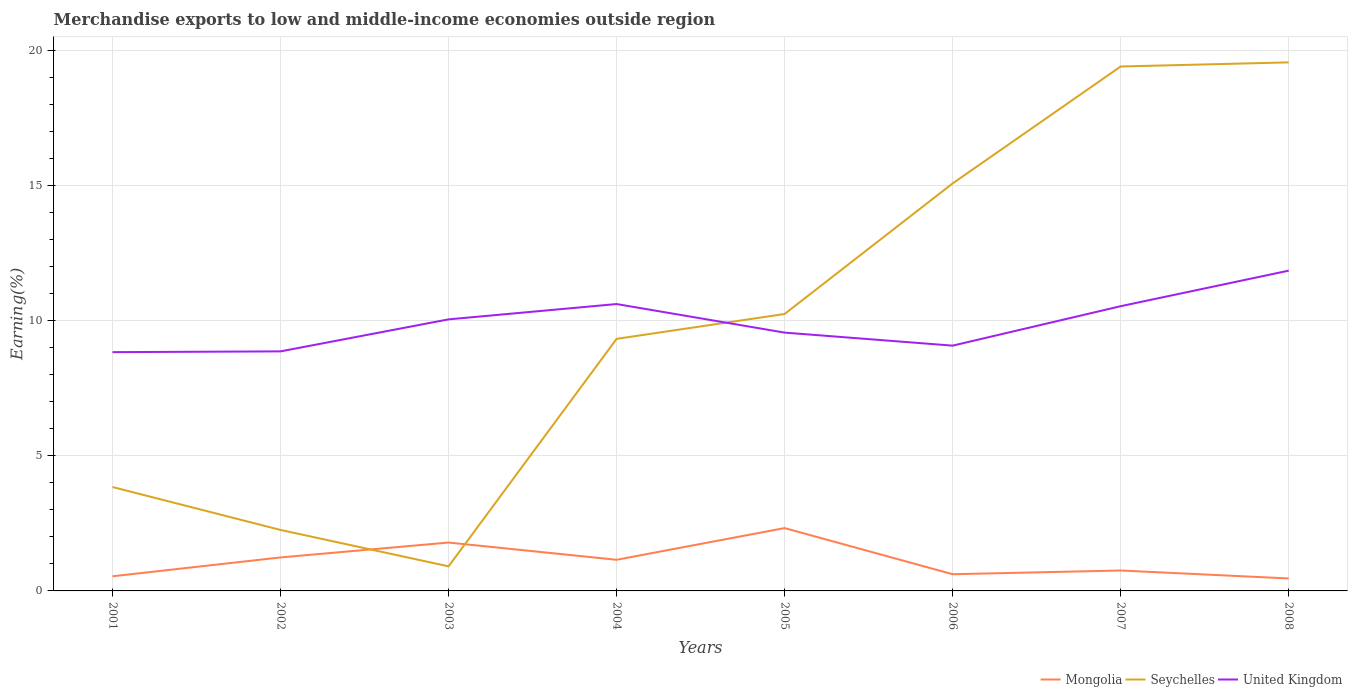Is the number of lines equal to the number of legend labels?
Your answer should be compact. Yes. Across all years, what is the maximum percentage of amount earned from merchandise exports in United Kingdom?
Provide a short and direct response. 8.83. In which year was the percentage of amount earned from merchandise exports in Seychelles maximum?
Provide a succinct answer. 2003. What is the total percentage of amount earned from merchandise exports in Mongolia in the graph?
Keep it short and to the point. 1.03. What is the difference between the highest and the second highest percentage of amount earned from merchandise exports in United Kingdom?
Your answer should be compact. 3.01. How many lines are there?
Offer a terse response. 3. How many years are there in the graph?
Provide a succinct answer. 8. Where does the legend appear in the graph?
Make the answer very short. Bottom right. How many legend labels are there?
Your answer should be compact. 3. How are the legend labels stacked?
Give a very brief answer. Horizontal. What is the title of the graph?
Make the answer very short. Merchandise exports to low and middle-income economies outside region. Does "Uzbekistan" appear as one of the legend labels in the graph?
Your response must be concise. No. What is the label or title of the X-axis?
Offer a very short reply. Years. What is the label or title of the Y-axis?
Ensure brevity in your answer.  Earning(%). What is the Earning(%) of Mongolia in 2001?
Give a very brief answer. 0.54. What is the Earning(%) in Seychelles in 2001?
Make the answer very short. 3.84. What is the Earning(%) of United Kingdom in 2001?
Your answer should be very brief. 8.83. What is the Earning(%) of Mongolia in 2002?
Your answer should be very brief. 1.24. What is the Earning(%) of Seychelles in 2002?
Ensure brevity in your answer.  2.25. What is the Earning(%) in United Kingdom in 2002?
Your answer should be very brief. 8.86. What is the Earning(%) in Mongolia in 2003?
Make the answer very short. 1.79. What is the Earning(%) of Seychelles in 2003?
Your answer should be very brief. 0.91. What is the Earning(%) in United Kingdom in 2003?
Offer a terse response. 10.04. What is the Earning(%) of Mongolia in 2004?
Ensure brevity in your answer.  1.15. What is the Earning(%) of Seychelles in 2004?
Offer a very short reply. 9.32. What is the Earning(%) of United Kingdom in 2004?
Make the answer very short. 10.61. What is the Earning(%) in Mongolia in 2005?
Offer a terse response. 2.32. What is the Earning(%) in Seychelles in 2005?
Keep it short and to the point. 10.24. What is the Earning(%) in United Kingdom in 2005?
Your response must be concise. 9.55. What is the Earning(%) of Mongolia in 2006?
Keep it short and to the point. 0.62. What is the Earning(%) in Seychelles in 2006?
Provide a short and direct response. 15.07. What is the Earning(%) of United Kingdom in 2006?
Offer a very short reply. 9.07. What is the Earning(%) of Mongolia in 2007?
Ensure brevity in your answer.  0.76. What is the Earning(%) in Seychelles in 2007?
Your answer should be compact. 19.39. What is the Earning(%) of United Kingdom in 2007?
Your answer should be compact. 10.53. What is the Earning(%) of Mongolia in 2008?
Keep it short and to the point. 0.46. What is the Earning(%) of Seychelles in 2008?
Provide a succinct answer. 19.54. What is the Earning(%) in United Kingdom in 2008?
Ensure brevity in your answer.  11.84. Across all years, what is the maximum Earning(%) in Mongolia?
Provide a succinct answer. 2.32. Across all years, what is the maximum Earning(%) in Seychelles?
Ensure brevity in your answer.  19.54. Across all years, what is the maximum Earning(%) of United Kingdom?
Ensure brevity in your answer.  11.84. Across all years, what is the minimum Earning(%) of Mongolia?
Offer a terse response. 0.46. Across all years, what is the minimum Earning(%) in Seychelles?
Your response must be concise. 0.91. Across all years, what is the minimum Earning(%) in United Kingdom?
Give a very brief answer. 8.83. What is the total Earning(%) in Mongolia in the graph?
Give a very brief answer. 8.88. What is the total Earning(%) in Seychelles in the graph?
Give a very brief answer. 80.57. What is the total Earning(%) of United Kingdom in the graph?
Offer a terse response. 79.33. What is the difference between the Earning(%) of Mongolia in 2001 and that in 2002?
Your response must be concise. -0.7. What is the difference between the Earning(%) of Seychelles in 2001 and that in 2002?
Your answer should be compact. 1.59. What is the difference between the Earning(%) of United Kingdom in 2001 and that in 2002?
Make the answer very short. -0.03. What is the difference between the Earning(%) of Mongolia in 2001 and that in 2003?
Provide a short and direct response. -1.25. What is the difference between the Earning(%) in Seychelles in 2001 and that in 2003?
Your response must be concise. 2.93. What is the difference between the Earning(%) in United Kingdom in 2001 and that in 2003?
Provide a short and direct response. -1.21. What is the difference between the Earning(%) in Mongolia in 2001 and that in 2004?
Offer a very short reply. -0.61. What is the difference between the Earning(%) in Seychelles in 2001 and that in 2004?
Your answer should be compact. -5.48. What is the difference between the Earning(%) in United Kingdom in 2001 and that in 2004?
Your answer should be very brief. -1.78. What is the difference between the Earning(%) of Mongolia in 2001 and that in 2005?
Ensure brevity in your answer.  -1.78. What is the difference between the Earning(%) of Seychelles in 2001 and that in 2005?
Provide a short and direct response. -6.4. What is the difference between the Earning(%) in United Kingdom in 2001 and that in 2005?
Ensure brevity in your answer.  -0.72. What is the difference between the Earning(%) of Mongolia in 2001 and that in 2006?
Provide a short and direct response. -0.08. What is the difference between the Earning(%) in Seychelles in 2001 and that in 2006?
Offer a terse response. -11.23. What is the difference between the Earning(%) in United Kingdom in 2001 and that in 2006?
Keep it short and to the point. -0.24. What is the difference between the Earning(%) of Mongolia in 2001 and that in 2007?
Provide a short and direct response. -0.21. What is the difference between the Earning(%) of Seychelles in 2001 and that in 2007?
Offer a terse response. -15.55. What is the difference between the Earning(%) of United Kingdom in 2001 and that in 2007?
Provide a short and direct response. -1.7. What is the difference between the Earning(%) of Mongolia in 2001 and that in 2008?
Your answer should be compact. 0.08. What is the difference between the Earning(%) in Seychelles in 2001 and that in 2008?
Your answer should be compact. -15.7. What is the difference between the Earning(%) in United Kingdom in 2001 and that in 2008?
Offer a terse response. -3.01. What is the difference between the Earning(%) in Mongolia in 2002 and that in 2003?
Keep it short and to the point. -0.55. What is the difference between the Earning(%) of Seychelles in 2002 and that in 2003?
Your response must be concise. 1.35. What is the difference between the Earning(%) of United Kingdom in 2002 and that in 2003?
Offer a terse response. -1.18. What is the difference between the Earning(%) of Mongolia in 2002 and that in 2004?
Provide a short and direct response. 0.09. What is the difference between the Earning(%) of Seychelles in 2002 and that in 2004?
Offer a very short reply. -7.07. What is the difference between the Earning(%) in United Kingdom in 2002 and that in 2004?
Offer a terse response. -1.75. What is the difference between the Earning(%) in Mongolia in 2002 and that in 2005?
Offer a very short reply. -1.09. What is the difference between the Earning(%) in Seychelles in 2002 and that in 2005?
Make the answer very short. -7.99. What is the difference between the Earning(%) of United Kingdom in 2002 and that in 2005?
Your answer should be compact. -0.69. What is the difference between the Earning(%) in Mongolia in 2002 and that in 2006?
Provide a succinct answer. 0.62. What is the difference between the Earning(%) of Seychelles in 2002 and that in 2006?
Offer a terse response. -12.81. What is the difference between the Earning(%) in United Kingdom in 2002 and that in 2006?
Offer a very short reply. -0.21. What is the difference between the Earning(%) in Mongolia in 2002 and that in 2007?
Ensure brevity in your answer.  0.48. What is the difference between the Earning(%) of Seychelles in 2002 and that in 2007?
Your answer should be very brief. -17.14. What is the difference between the Earning(%) in United Kingdom in 2002 and that in 2007?
Your response must be concise. -1.67. What is the difference between the Earning(%) in Mongolia in 2002 and that in 2008?
Give a very brief answer. 0.78. What is the difference between the Earning(%) in Seychelles in 2002 and that in 2008?
Keep it short and to the point. -17.29. What is the difference between the Earning(%) in United Kingdom in 2002 and that in 2008?
Your response must be concise. -2.99. What is the difference between the Earning(%) in Mongolia in 2003 and that in 2004?
Offer a terse response. 0.64. What is the difference between the Earning(%) of Seychelles in 2003 and that in 2004?
Offer a very short reply. -8.41. What is the difference between the Earning(%) of United Kingdom in 2003 and that in 2004?
Offer a terse response. -0.57. What is the difference between the Earning(%) in Mongolia in 2003 and that in 2005?
Your answer should be compact. -0.53. What is the difference between the Earning(%) in Seychelles in 2003 and that in 2005?
Make the answer very short. -9.33. What is the difference between the Earning(%) of United Kingdom in 2003 and that in 2005?
Give a very brief answer. 0.49. What is the difference between the Earning(%) of Mongolia in 2003 and that in 2006?
Provide a succinct answer. 1.17. What is the difference between the Earning(%) of Seychelles in 2003 and that in 2006?
Offer a very short reply. -14.16. What is the difference between the Earning(%) of United Kingdom in 2003 and that in 2006?
Your answer should be very brief. 0.97. What is the difference between the Earning(%) in Mongolia in 2003 and that in 2007?
Your answer should be compact. 1.03. What is the difference between the Earning(%) of Seychelles in 2003 and that in 2007?
Provide a short and direct response. -18.48. What is the difference between the Earning(%) of United Kingdom in 2003 and that in 2007?
Give a very brief answer. -0.49. What is the difference between the Earning(%) of Mongolia in 2003 and that in 2008?
Make the answer very short. 1.33. What is the difference between the Earning(%) of Seychelles in 2003 and that in 2008?
Provide a succinct answer. -18.64. What is the difference between the Earning(%) of United Kingdom in 2003 and that in 2008?
Ensure brevity in your answer.  -1.8. What is the difference between the Earning(%) in Mongolia in 2004 and that in 2005?
Keep it short and to the point. -1.17. What is the difference between the Earning(%) of Seychelles in 2004 and that in 2005?
Provide a succinct answer. -0.92. What is the difference between the Earning(%) in United Kingdom in 2004 and that in 2005?
Keep it short and to the point. 1.06. What is the difference between the Earning(%) in Mongolia in 2004 and that in 2006?
Offer a terse response. 0.53. What is the difference between the Earning(%) of Seychelles in 2004 and that in 2006?
Make the answer very short. -5.75. What is the difference between the Earning(%) in United Kingdom in 2004 and that in 2006?
Ensure brevity in your answer.  1.54. What is the difference between the Earning(%) of Mongolia in 2004 and that in 2007?
Your answer should be compact. 0.4. What is the difference between the Earning(%) of Seychelles in 2004 and that in 2007?
Keep it short and to the point. -10.07. What is the difference between the Earning(%) of United Kingdom in 2004 and that in 2007?
Offer a terse response. 0.08. What is the difference between the Earning(%) of Mongolia in 2004 and that in 2008?
Provide a succinct answer. 0.69. What is the difference between the Earning(%) in Seychelles in 2004 and that in 2008?
Your answer should be compact. -10.22. What is the difference between the Earning(%) in United Kingdom in 2004 and that in 2008?
Keep it short and to the point. -1.24. What is the difference between the Earning(%) in Mongolia in 2005 and that in 2006?
Your response must be concise. 1.71. What is the difference between the Earning(%) of Seychelles in 2005 and that in 2006?
Keep it short and to the point. -4.83. What is the difference between the Earning(%) of United Kingdom in 2005 and that in 2006?
Offer a very short reply. 0.48. What is the difference between the Earning(%) in Mongolia in 2005 and that in 2007?
Offer a very short reply. 1.57. What is the difference between the Earning(%) in Seychelles in 2005 and that in 2007?
Your answer should be very brief. -9.15. What is the difference between the Earning(%) in United Kingdom in 2005 and that in 2007?
Give a very brief answer. -0.98. What is the difference between the Earning(%) of Mongolia in 2005 and that in 2008?
Give a very brief answer. 1.86. What is the difference between the Earning(%) in Seychelles in 2005 and that in 2008?
Provide a short and direct response. -9.3. What is the difference between the Earning(%) of United Kingdom in 2005 and that in 2008?
Ensure brevity in your answer.  -2.29. What is the difference between the Earning(%) of Mongolia in 2006 and that in 2007?
Your answer should be very brief. -0.14. What is the difference between the Earning(%) in Seychelles in 2006 and that in 2007?
Provide a succinct answer. -4.32. What is the difference between the Earning(%) of United Kingdom in 2006 and that in 2007?
Keep it short and to the point. -1.46. What is the difference between the Earning(%) in Mongolia in 2006 and that in 2008?
Provide a short and direct response. 0.16. What is the difference between the Earning(%) of Seychelles in 2006 and that in 2008?
Make the answer very short. -4.48. What is the difference between the Earning(%) in United Kingdom in 2006 and that in 2008?
Provide a succinct answer. -2.77. What is the difference between the Earning(%) of Mongolia in 2007 and that in 2008?
Your answer should be very brief. 0.29. What is the difference between the Earning(%) in Seychelles in 2007 and that in 2008?
Give a very brief answer. -0.15. What is the difference between the Earning(%) in United Kingdom in 2007 and that in 2008?
Provide a short and direct response. -1.31. What is the difference between the Earning(%) in Mongolia in 2001 and the Earning(%) in Seychelles in 2002?
Ensure brevity in your answer.  -1.71. What is the difference between the Earning(%) of Mongolia in 2001 and the Earning(%) of United Kingdom in 2002?
Provide a succinct answer. -8.32. What is the difference between the Earning(%) of Seychelles in 2001 and the Earning(%) of United Kingdom in 2002?
Your answer should be very brief. -5.02. What is the difference between the Earning(%) of Mongolia in 2001 and the Earning(%) of Seychelles in 2003?
Your answer should be very brief. -0.37. What is the difference between the Earning(%) of Mongolia in 2001 and the Earning(%) of United Kingdom in 2003?
Your answer should be very brief. -9.5. What is the difference between the Earning(%) in Seychelles in 2001 and the Earning(%) in United Kingdom in 2003?
Your answer should be compact. -6.2. What is the difference between the Earning(%) in Mongolia in 2001 and the Earning(%) in Seychelles in 2004?
Keep it short and to the point. -8.78. What is the difference between the Earning(%) of Mongolia in 2001 and the Earning(%) of United Kingdom in 2004?
Give a very brief answer. -10.07. What is the difference between the Earning(%) in Seychelles in 2001 and the Earning(%) in United Kingdom in 2004?
Your answer should be compact. -6.77. What is the difference between the Earning(%) of Mongolia in 2001 and the Earning(%) of Seychelles in 2005?
Keep it short and to the point. -9.7. What is the difference between the Earning(%) in Mongolia in 2001 and the Earning(%) in United Kingdom in 2005?
Provide a succinct answer. -9.01. What is the difference between the Earning(%) in Seychelles in 2001 and the Earning(%) in United Kingdom in 2005?
Ensure brevity in your answer.  -5.71. What is the difference between the Earning(%) in Mongolia in 2001 and the Earning(%) in Seychelles in 2006?
Provide a succinct answer. -14.53. What is the difference between the Earning(%) of Mongolia in 2001 and the Earning(%) of United Kingdom in 2006?
Provide a short and direct response. -8.53. What is the difference between the Earning(%) in Seychelles in 2001 and the Earning(%) in United Kingdom in 2006?
Offer a very short reply. -5.23. What is the difference between the Earning(%) of Mongolia in 2001 and the Earning(%) of Seychelles in 2007?
Provide a succinct answer. -18.85. What is the difference between the Earning(%) of Mongolia in 2001 and the Earning(%) of United Kingdom in 2007?
Give a very brief answer. -9.99. What is the difference between the Earning(%) of Seychelles in 2001 and the Earning(%) of United Kingdom in 2007?
Make the answer very short. -6.69. What is the difference between the Earning(%) in Mongolia in 2001 and the Earning(%) in Seychelles in 2008?
Offer a very short reply. -19. What is the difference between the Earning(%) of Mongolia in 2001 and the Earning(%) of United Kingdom in 2008?
Offer a terse response. -11.3. What is the difference between the Earning(%) of Seychelles in 2001 and the Earning(%) of United Kingdom in 2008?
Keep it short and to the point. -8. What is the difference between the Earning(%) in Mongolia in 2002 and the Earning(%) in Seychelles in 2003?
Offer a terse response. 0.33. What is the difference between the Earning(%) of Mongolia in 2002 and the Earning(%) of United Kingdom in 2003?
Make the answer very short. -8.8. What is the difference between the Earning(%) in Seychelles in 2002 and the Earning(%) in United Kingdom in 2003?
Give a very brief answer. -7.79. What is the difference between the Earning(%) of Mongolia in 2002 and the Earning(%) of Seychelles in 2004?
Your answer should be very brief. -8.08. What is the difference between the Earning(%) of Mongolia in 2002 and the Earning(%) of United Kingdom in 2004?
Your answer should be compact. -9.37. What is the difference between the Earning(%) in Seychelles in 2002 and the Earning(%) in United Kingdom in 2004?
Offer a very short reply. -8.35. What is the difference between the Earning(%) of Mongolia in 2002 and the Earning(%) of Seychelles in 2005?
Provide a short and direct response. -9. What is the difference between the Earning(%) in Mongolia in 2002 and the Earning(%) in United Kingdom in 2005?
Give a very brief answer. -8.31. What is the difference between the Earning(%) of Seychelles in 2002 and the Earning(%) of United Kingdom in 2005?
Your answer should be compact. -7.3. What is the difference between the Earning(%) in Mongolia in 2002 and the Earning(%) in Seychelles in 2006?
Provide a succinct answer. -13.83. What is the difference between the Earning(%) of Mongolia in 2002 and the Earning(%) of United Kingdom in 2006?
Make the answer very short. -7.83. What is the difference between the Earning(%) in Seychelles in 2002 and the Earning(%) in United Kingdom in 2006?
Your answer should be compact. -6.82. What is the difference between the Earning(%) in Mongolia in 2002 and the Earning(%) in Seychelles in 2007?
Offer a terse response. -18.15. What is the difference between the Earning(%) in Mongolia in 2002 and the Earning(%) in United Kingdom in 2007?
Your response must be concise. -9.29. What is the difference between the Earning(%) of Seychelles in 2002 and the Earning(%) of United Kingdom in 2007?
Give a very brief answer. -8.27. What is the difference between the Earning(%) of Mongolia in 2002 and the Earning(%) of Seychelles in 2008?
Make the answer very short. -18.31. What is the difference between the Earning(%) of Mongolia in 2002 and the Earning(%) of United Kingdom in 2008?
Your response must be concise. -10.61. What is the difference between the Earning(%) in Seychelles in 2002 and the Earning(%) in United Kingdom in 2008?
Make the answer very short. -9.59. What is the difference between the Earning(%) of Mongolia in 2003 and the Earning(%) of Seychelles in 2004?
Your answer should be compact. -7.53. What is the difference between the Earning(%) in Mongolia in 2003 and the Earning(%) in United Kingdom in 2004?
Ensure brevity in your answer.  -8.82. What is the difference between the Earning(%) of Seychelles in 2003 and the Earning(%) of United Kingdom in 2004?
Offer a very short reply. -9.7. What is the difference between the Earning(%) of Mongolia in 2003 and the Earning(%) of Seychelles in 2005?
Your response must be concise. -8.45. What is the difference between the Earning(%) of Mongolia in 2003 and the Earning(%) of United Kingdom in 2005?
Provide a short and direct response. -7.76. What is the difference between the Earning(%) of Seychelles in 2003 and the Earning(%) of United Kingdom in 2005?
Provide a short and direct response. -8.64. What is the difference between the Earning(%) in Mongolia in 2003 and the Earning(%) in Seychelles in 2006?
Keep it short and to the point. -13.28. What is the difference between the Earning(%) of Mongolia in 2003 and the Earning(%) of United Kingdom in 2006?
Ensure brevity in your answer.  -7.28. What is the difference between the Earning(%) of Seychelles in 2003 and the Earning(%) of United Kingdom in 2006?
Offer a terse response. -8.16. What is the difference between the Earning(%) of Mongolia in 2003 and the Earning(%) of Seychelles in 2007?
Offer a terse response. -17.6. What is the difference between the Earning(%) of Mongolia in 2003 and the Earning(%) of United Kingdom in 2007?
Offer a terse response. -8.74. What is the difference between the Earning(%) of Seychelles in 2003 and the Earning(%) of United Kingdom in 2007?
Your answer should be very brief. -9.62. What is the difference between the Earning(%) of Mongolia in 2003 and the Earning(%) of Seychelles in 2008?
Your answer should be very brief. -17.76. What is the difference between the Earning(%) of Mongolia in 2003 and the Earning(%) of United Kingdom in 2008?
Your answer should be very brief. -10.05. What is the difference between the Earning(%) in Seychelles in 2003 and the Earning(%) in United Kingdom in 2008?
Give a very brief answer. -10.93. What is the difference between the Earning(%) in Mongolia in 2004 and the Earning(%) in Seychelles in 2005?
Your answer should be compact. -9.09. What is the difference between the Earning(%) of Mongolia in 2004 and the Earning(%) of United Kingdom in 2005?
Give a very brief answer. -8.4. What is the difference between the Earning(%) of Seychelles in 2004 and the Earning(%) of United Kingdom in 2005?
Keep it short and to the point. -0.23. What is the difference between the Earning(%) of Mongolia in 2004 and the Earning(%) of Seychelles in 2006?
Your response must be concise. -13.92. What is the difference between the Earning(%) in Mongolia in 2004 and the Earning(%) in United Kingdom in 2006?
Offer a terse response. -7.92. What is the difference between the Earning(%) of Seychelles in 2004 and the Earning(%) of United Kingdom in 2006?
Offer a terse response. 0.25. What is the difference between the Earning(%) in Mongolia in 2004 and the Earning(%) in Seychelles in 2007?
Give a very brief answer. -18.24. What is the difference between the Earning(%) in Mongolia in 2004 and the Earning(%) in United Kingdom in 2007?
Your answer should be compact. -9.38. What is the difference between the Earning(%) of Seychelles in 2004 and the Earning(%) of United Kingdom in 2007?
Keep it short and to the point. -1.21. What is the difference between the Earning(%) in Mongolia in 2004 and the Earning(%) in Seychelles in 2008?
Make the answer very short. -18.39. What is the difference between the Earning(%) of Mongolia in 2004 and the Earning(%) of United Kingdom in 2008?
Make the answer very short. -10.69. What is the difference between the Earning(%) in Seychelles in 2004 and the Earning(%) in United Kingdom in 2008?
Give a very brief answer. -2.52. What is the difference between the Earning(%) in Mongolia in 2005 and the Earning(%) in Seychelles in 2006?
Give a very brief answer. -12.75. What is the difference between the Earning(%) in Mongolia in 2005 and the Earning(%) in United Kingdom in 2006?
Ensure brevity in your answer.  -6.75. What is the difference between the Earning(%) in Seychelles in 2005 and the Earning(%) in United Kingdom in 2006?
Offer a very short reply. 1.17. What is the difference between the Earning(%) of Mongolia in 2005 and the Earning(%) of Seychelles in 2007?
Provide a succinct answer. -17.07. What is the difference between the Earning(%) of Mongolia in 2005 and the Earning(%) of United Kingdom in 2007?
Your answer should be compact. -8.21. What is the difference between the Earning(%) of Seychelles in 2005 and the Earning(%) of United Kingdom in 2007?
Ensure brevity in your answer.  -0.29. What is the difference between the Earning(%) of Mongolia in 2005 and the Earning(%) of Seychelles in 2008?
Make the answer very short. -17.22. What is the difference between the Earning(%) of Mongolia in 2005 and the Earning(%) of United Kingdom in 2008?
Keep it short and to the point. -9.52. What is the difference between the Earning(%) of Seychelles in 2005 and the Earning(%) of United Kingdom in 2008?
Provide a short and direct response. -1.6. What is the difference between the Earning(%) in Mongolia in 2006 and the Earning(%) in Seychelles in 2007?
Give a very brief answer. -18.78. What is the difference between the Earning(%) of Mongolia in 2006 and the Earning(%) of United Kingdom in 2007?
Offer a very short reply. -9.91. What is the difference between the Earning(%) of Seychelles in 2006 and the Earning(%) of United Kingdom in 2007?
Provide a short and direct response. 4.54. What is the difference between the Earning(%) of Mongolia in 2006 and the Earning(%) of Seychelles in 2008?
Keep it short and to the point. -18.93. What is the difference between the Earning(%) in Mongolia in 2006 and the Earning(%) in United Kingdom in 2008?
Your answer should be very brief. -11.23. What is the difference between the Earning(%) in Seychelles in 2006 and the Earning(%) in United Kingdom in 2008?
Offer a very short reply. 3.23. What is the difference between the Earning(%) in Mongolia in 2007 and the Earning(%) in Seychelles in 2008?
Keep it short and to the point. -18.79. What is the difference between the Earning(%) of Mongolia in 2007 and the Earning(%) of United Kingdom in 2008?
Offer a terse response. -11.09. What is the difference between the Earning(%) in Seychelles in 2007 and the Earning(%) in United Kingdom in 2008?
Provide a succinct answer. 7.55. What is the average Earning(%) of Mongolia per year?
Make the answer very short. 1.11. What is the average Earning(%) in Seychelles per year?
Your response must be concise. 10.07. What is the average Earning(%) in United Kingdom per year?
Keep it short and to the point. 9.92. In the year 2001, what is the difference between the Earning(%) of Mongolia and Earning(%) of Seychelles?
Ensure brevity in your answer.  -3.3. In the year 2001, what is the difference between the Earning(%) in Mongolia and Earning(%) in United Kingdom?
Offer a terse response. -8.29. In the year 2001, what is the difference between the Earning(%) of Seychelles and Earning(%) of United Kingdom?
Keep it short and to the point. -4.99. In the year 2002, what is the difference between the Earning(%) of Mongolia and Earning(%) of Seychelles?
Offer a very short reply. -1.02. In the year 2002, what is the difference between the Earning(%) of Mongolia and Earning(%) of United Kingdom?
Provide a succinct answer. -7.62. In the year 2002, what is the difference between the Earning(%) of Seychelles and Earning(%) of United Kingdom?
Your answer should be very brief. -6.6. In the year 2003, what is the difference between the Earning(%) in Mongolia and Earning(%) in Seychelles?
Your answer should be very brief. 0.88. In the year 2003, what is the difference between the Earning(%) of Mongolia and Earning(%) of United Kingdom?
Offer a terse response. -8.25. In the year 2003, what is the difference between the Earning(%) of Seychelles and Earning(%) of United Kingdom?
Provide a succinct answer. -9.13. In the year 2004, what is the difference between the Earning(%) of Mongolia and Earning(%) of Seychelles?
Your answer should be compact. -8.17. In the year 2004, what is the difference between the Earning(%) in Mongolia and Earning(%) in United Kingdom?
Offer a terse response. -9.46. In the year 2004, what is the difference between the Earning(%) in Seychelles and Earning(%) in United Kingdom?
Your answer should be very brief. -1.29. In the year 2005, what is the difference between the Earning(%) of Mongolia and Earning(%) of Seychelles?
Your answer should be compact. -7.92. In the year 2005, what is the difference between the Earning(%) in Mongolia and Earning(%) in United Kingdom?
Your response must be concise. -7.23. In the year 2005, what is the difference between the Earning(%) in Seychelles and Earning(%) in United Kingdom?
Offer a very short reply. 0.69. In the year 2006, what is the difference between the Earning(%) in Mongolia and Earning(%) in Seychelles?
Ensure brevity in your answer.  -14.45. In the year 2006, what is the difference between the Earning(%) in Mongolia and Earning(%) in United Kingdom?
Your answer should be compact. -8.45. In the year 2006, what is the difference between the Earning(%) of Seychelles and Earning(%) of United Kingdom?
Your response must be concise. 6. In the year 2007, what is the difference between the Earning(%) of Mongolia and Earning(%) of Seychelles?
Make the answer very short. -18.64. In the year 2007, what is the difference between the Earning(%) of Mongolia and Earning(%) of United Kingdom?
Your answer should be compact. -9.77. In the year 2007, what is the difference between the Earning(%) in Seychelles and Earning(%) in United Kingdom?
Keep it short and to the point. 8.86. In the year 2008, what is the difference between the Earning(%) of Mongolia and Earning(%) of Seychelles?
Make the answer very short. -19.08. In the year 2008, what is the difference between the Earning(%) of Mongolia and Earning(%) of United Kingdom?
Provide a short and direct response. -11.38. In the year 2008, what is the difference between the Earning(%) in Seychelles and Earning(%) in United Kingdom?
Your answer should be compact. 7.7. What is the ratio of the Earning(%) in Mongolia in 2001 to that in 2002?
Your answer should be compact. 0.44. What is the ratio of the Earning(%) in Seychelles in 2001 to that in 2002?
Your answer should be compact. 1.7. What is the ratio of the Earning(%) in Mongolia in 2001 to that in 2003?
Make the answer very short. 0.3. What is the ratio of the Earning(%) of Seychelles in 2001 to that in 2003?
Ensure brevity in your answer.  4.23. What is the ratio of the Earning(%) in United Kingdom in 2001 to that in 2003?
Give a very brief answer. 0.88. What is the ratio of the Earning(%) in Mongolia in 2001 to that in 2004?
Offer a terse response. 0.47. What is the ratio of the Earning(%) in Seychelles in 2001 to that in 2004?
Your response must be concise. 0.41. What is the ratio of the Earning(%) of United Kingdom in 2001 to that in 2004?
Offer a terse response. 0.83. What is the ratio of the Earning(%) of Mongolia in 2001 to that in 2005?
Offer a terse response. 0.23. What is the ratio of the Earning(%) of Seychelles in 2001 to that in 2005?
Keep it short and to the point. 0.38. What is the ratio of the Earning(%) in United Kingdom in 2001 to that in 2005?
Ensure brevity in your answer.  0.92. What is the ratio of the Earning(%) in Mongolia in 2001 to that in 2006?
Offer a terse response. 0.88. What is the ratio of the Earning(%) of Seychelles in 2001 to that in 2006?
Your answer should be very brief. 0.25. What is the ratio of the Earning(%) of United Kingdom in 2001 to that in 2006?
Give a very brief answer. 0.97. What is the ratio of the Earning(%) in Mongolia in 2001 to that in 2007?
Provide a short and direct response. 0.72. What is the ratio of the Earning(%) in Seychelles in 2001 to that in 2007?
Your answer should be very brief. 0.2. What is the ratio of the Earning(%) of United Kingdom in 2001 to that in 2007?
Your answer should be very brief. 0.84. What is the ratio of the Earning(%) in Mongolia in 2001 to that in 2008?
Ensure brevity in your answer.  1.18. What is the ratio of the Earning(%) of Seychelles in 2001 to that in 2008?
Your answer should be very brief. 0.2. What is the ratio of the Earning(%) of United Kingdom in 2001 to that in 2008?
Make the answer very short. 0.75. What is the ratio of the Earning(%) in Mongolia in 2002 to that in 2003?
Make the answer very short. 0.69. What is the ratio of the Earning(%) of Seychelles in 2002 to that in 2003?
Keep it short and to the point. 2.48. What is the ratio of the Earning(%) of United Kingdom in 2002 to that in 2003?
Provide a short and direct response. 0.88. What is the ratio of the Earning(%) in Mongolia in 2002 to that in 2004?
Make the answer very short. 1.08. What is the ratio of the Earning(%) in Seychelles in 2002 to that in 2004?
Ensure brevity in your answer.  0.24. What is the ratio of the Earning(%) in United Kingdom in 2002 to that in 2004?
Offer a very short reply. 0.83. What is the ratio of the Earning(%) of Mongolia in 2002 to that in 2005?
Offer a very short reply. 0.53. What is the ratio of the Earning(%) in Seychelles in 2002 to that in 2005?
Give a very brief answer. 0.22. What is the ratio of the Earning(%) in United Kingdom in 2002 to that in 2005?
Offer a very short reply. 0.93. What is the ratio of the Earning(%) in Mongolia in 2002 to that in 2006?
Make the answer very short. 2.01. What is the ratio of the Earning(%) in Seychelles in 2002 to that in 2006?
Offer a very short reply. 0.15. What is the ratio of the Earning(%) of United Kingdom in 2002 to that in 2006?
Provide a short and direct response. 0.98. What is the ratio of the Earning(%) of Mongolia in 2002 to that in 2007?
Keep it short and to the point. 1.64. What is the ratio of the Earning(%) of Seychelles in 2002 to that in 2007?
Provide a succinct answer. 0.12. What is the ratio of the Earning(%) of United Kingdom in 2002 to that in 2007?
Give a very brief answer. 0.84. What is the ratio of the Earning(%) of Mongolia in 2002 to that in 2008?
Give a very brief answer. 2.69. What is the ratio of the Earning(%) of Seychelles in 2002 to that in 2008?
Provide a succinct answer. 0.12. What is the ratio of the Earning(%) of United Kingdom in 2002 to that in 2008?
Make the answer very short. 0.75. What is the ratio of the Earning(%) in Mongolia in 2003 to that in 2004?
Ensure brevity in your answer.  1.55. What is the ratio of the Earning(%) in Seychelles in 2003 to that in 2004?
Keep it short and to the point. 0.1. What is the ratio of the Earning(%) in United Kingdom in 2003 to that in 2004?
Your answer should be very brief. 0.95. What is the ratio of the Earning(%) of Mongolia in 2003 to that in 2005?
Provide a succinct answer. 0.77. What is the ratio of the Earning(%) in Seychelles in 2003 to that in 2005?
Provide a short and direct response. 0.09. What is the ratio of the Earning(%) in United Kingdom in 2003 to that in 2005?
Your answer should be compact. 1.05. What is the ratio of the Earning(%) of Mongolia in 2003 to that in 2006?
Provide a short and direct response. 2.9. What is the ratio of the Earning(%) in Seychelles in 2003 to that in 2006?
Make the answer very short. 0.06. What is the ratio of the Earning(%) in United Kingdom in 2003 to that in 2006?
Make the answer very short. 1.11. What is the ratio of the Earning(%) of Mongolia in 2003 to that in 2007?
Provide a succinct answer. 2.37. What is the ratio of the Earning(%) of Seychelles in 2003 to that in 2007?
Keep it short and to the point. 0.05. What is the ratio of the Earning(%) of United Kingdom in 2003 to that in 2007?
Make the answer very short. 0.95. What is the ratio of the Earning(%) in Mongolia in 2003 to that in 2008?
Provide a succinct answer. 3.88. What is the ratio of the Earning(%) of Seychelles in 2003 to that in 2008?
Your answer should be very brief. 0.05. What is the ratio of the Earning(%) of United Kingdom in 2003 to that in 2008?
Your answer should be very brief. 0.85. What is the ratio of the Earning(%) in Mongolia in 2004 to that in 2005?
Your answer should be very brief. 0.5. What is the ratio of the Earning(%) in Seychelles in 2004 to that in 2005?
Provide a succinct answer. 0.91. What is the ratio of the Earning(%) of United Kingdom in 2004 to that in 2005?
Ensure brevity in your answer.  1.11. What is the ratio of the Earning(%) of Mongolia in 2004 to that in 2006?
Give a very brief answer. 1.86. What is the ratio of the Earning(%) in Seychelles in 2004 to that in 2006?
Your answer should be compact. 0.62. What is the ratio of the Earning(%) in United Kingdom in 2004 to that in 2006?
Provide a short and direct response. 1.17. What is the ratio of the Earning(%) of Mongolia in 2004 to that in 2007?
Ensure brevity in your answer.  1.52. What is the ratio of the Earning(%) of Seychelles in 2004 to that in 2007?
Provide a succinct answer. 0.48. What is the ratio of the Earning(%) of United Kingdom in 2004 to that in 2007?
Make the answer very short. 1.01. What is the ratio of the Earning(%) in Mongolia in 2004 to that in 2008?
Offer a terse response. 2.5. What is the ratio of the Earning(%) of Seychelles in 2004 to that in 2008?
Offer a terse response. 0.48. What is the ratio of the Earning(%) in United Kingdom in 2004 to that in 2008?
Offer a very short reply. 0.9. What is the ratio of the Earning(%) of Mongolia in 2005 to that in 2006?
Your answer should be compact. 3.76. What is the ratio of the Earning(%) in Seychelles in 2005 to that in 2006?
Ensure brevity in your answer.  0.68. What is the ratio of the Earning(%) of United Kingdom in 2005 to that in 2006?
Give a very brief answer. 1.05. What is the ratio of the Earning(%) in Mongolia in 2005 to that in 2007?
Make the answer very short. 3.08. What is the ratio of the Earning(%) of Seychelles in 2005 to that in 2007?
Offer a very short reply. 0.53. What is the ratio of the Earning(%) in United Kingdom in 2005 to that in 2007?
Give a very brief answer. 0.91. What is the ratio of the Earning(%) of Mongolia in 2005 to that in 2008?
Provide a short and direct response. 5.04. What is the ratio of the Earning(%) in Seychelles in 2005 to that in 2008?
Offer a very short reply. 0.52. What is the ratio of the Earning(%) in United Kingdom in 2005 to that in 2008?
Offer a very short reply. 0.81. What is the ratio of the Earning(%) of Mongolia in 2006 to that in 2007?
Ensure brevity in your answer.  0.82. What is the ratio of the Earning(%) in Seychelles in 2006 to that in 2007?
Provide a short and direct response. 0.78. What is the ratio of the Earning(%) of United Kingdom in 2006 to that in 2007?
Your answer should be compact. 0.86. What is the ratio of the Earning(%) in Mongolia in 2006 to that in 2008?
Provide a short and direct response. 1.34. What is the ratio of the Earning(%) of Seychelles in 2006 to that in 2008?
Make the answer very short. 0.77. What is the ratio of the Earning(%) of United Kingdom in 2006 to that in 2008?
Offer a terse response. 0.77. What is the ratio of the Earning(%) of Mongolia in 2007 to that in 2008?
Give a very brief answer. 1.64. What is the ratio of the Earning(%) of United Kingdom in 2007 to that in 2008?
Provide a succinct answer. 0.89. What is the difference between the highest and the second highest Earning(%) of Mongolia?
Keep it short and to the point. 0.53. What is the difference between the highest and the second highest Earning(%) in Seychelles?
Your answer should be compact. 0.15. What is the difference between the highest and the second highest Earning(%) in United Kingdom?
Make the answer very short. 1.24. What is the difference between the highest and the lowest Earning(%) of Mongolia?
Provide a short and direct response. 1.86. What is the difference between the highest and the lowest Earning(%) of Seychelles?
Your answer should be compact. 18.64. What is the difference between the highest and the lowest Earning(%) in United Kingdom?
Offer a terse response. 3.01. 